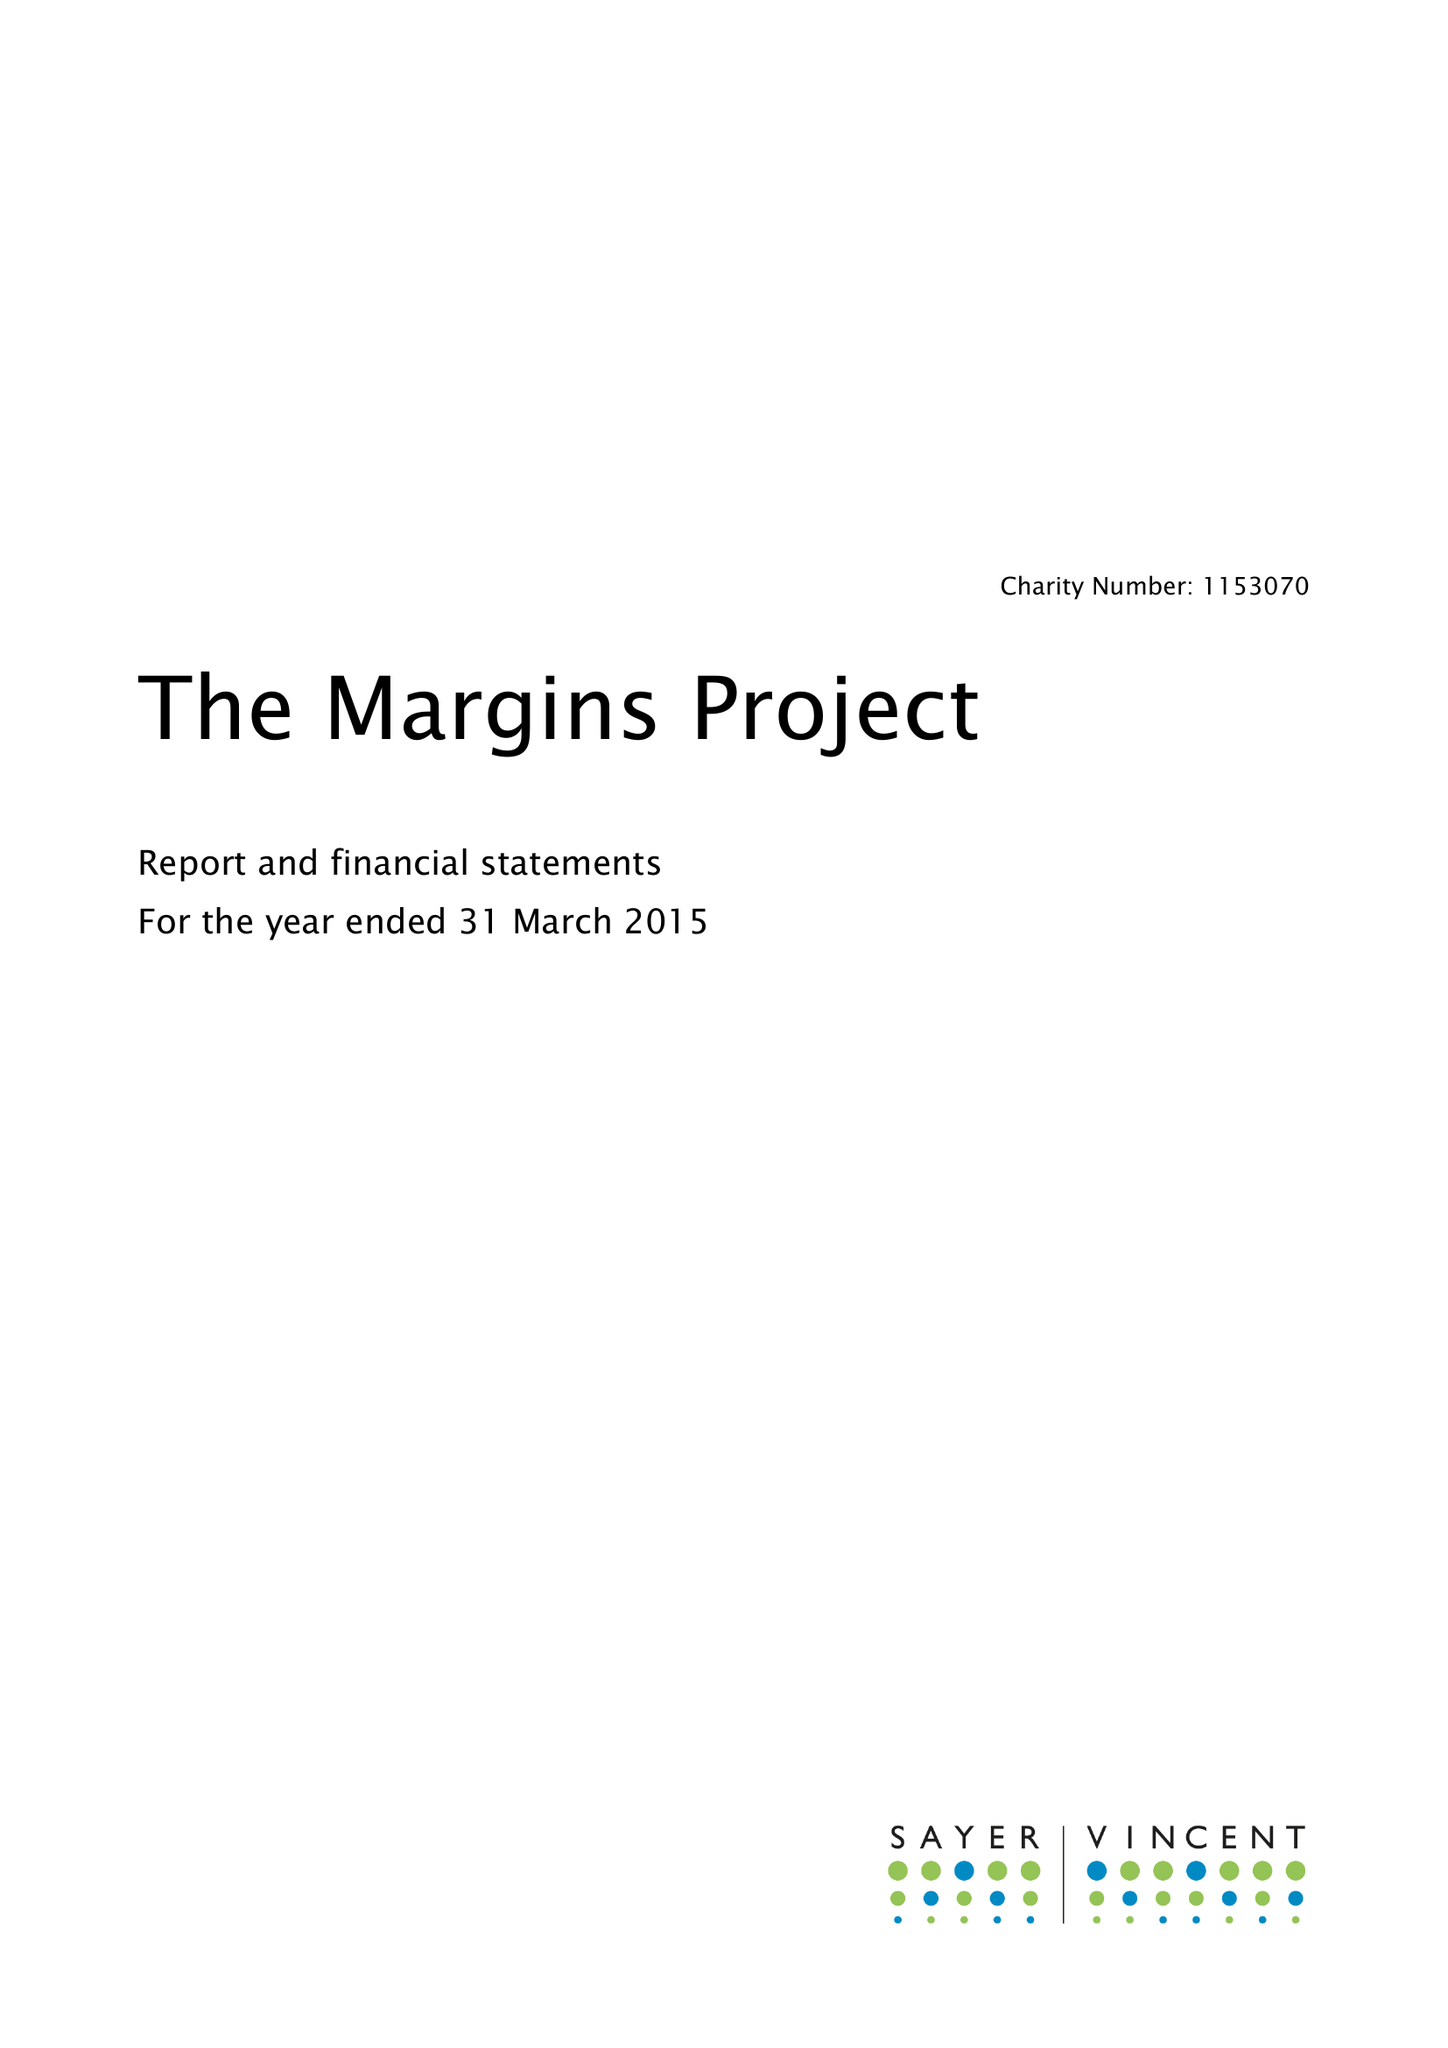What is the value for the report_date?
Answer the question using a single word or phrase. 2015-03-31 